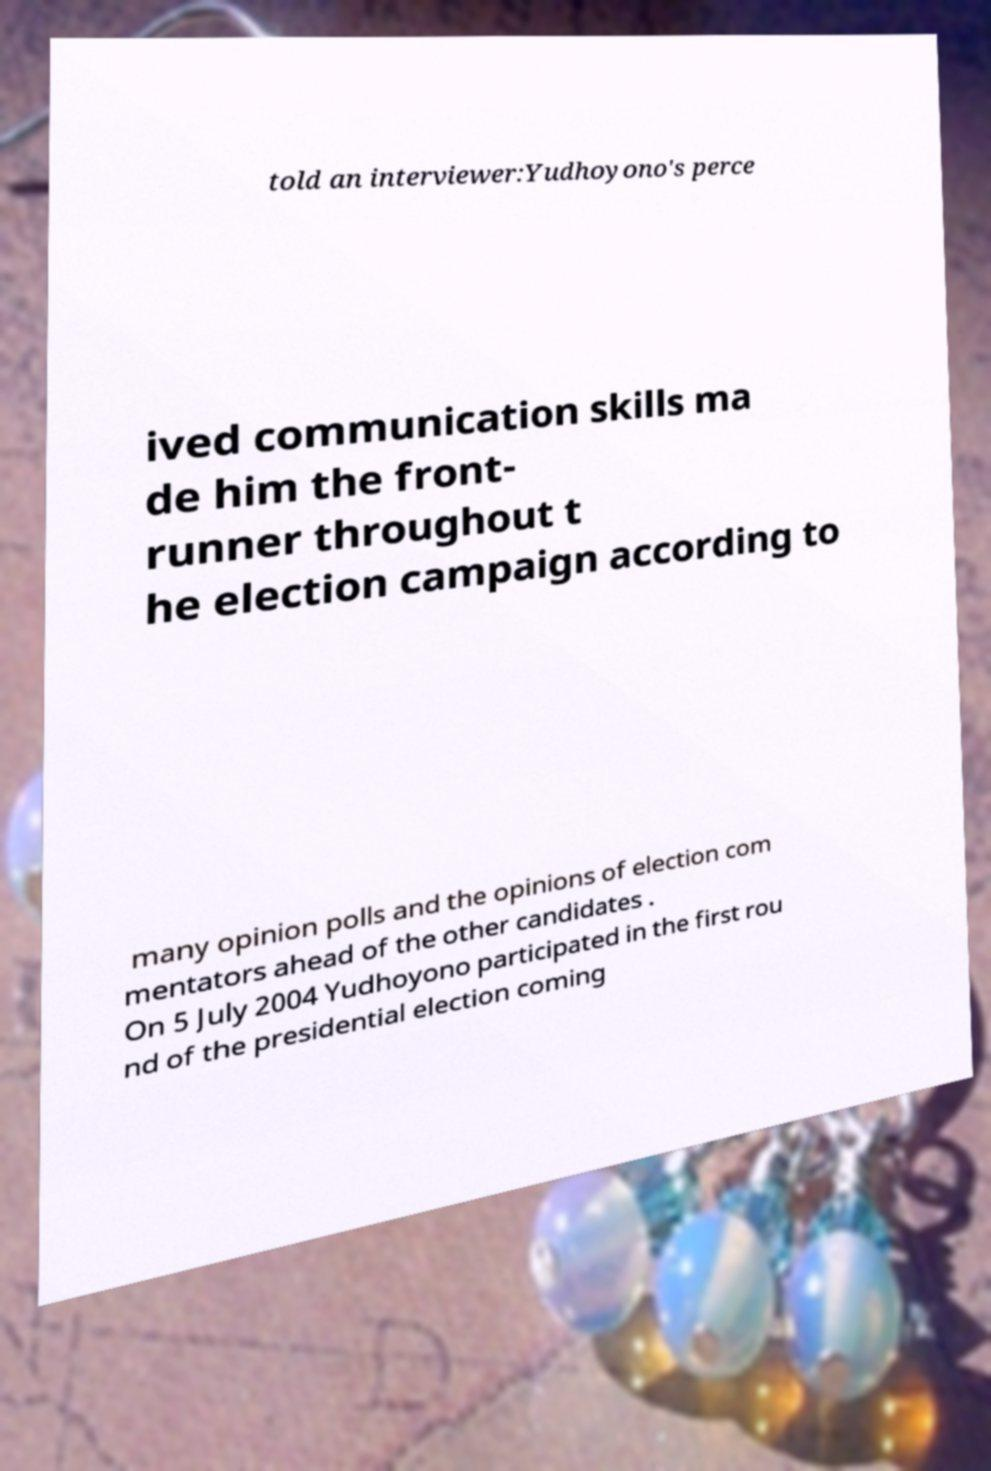I need the written content from this picture converted into text. Can you do that? told an interviewer:Yudhoyono's perce ived communication skills ma de him the front- runner throughout t he election campaign according to many opinion polls and the opinions of election com mentators ahead of the other candidates . On 5 July 2004 Yudhoyono participated in the first rou nd of the presidential election coming 